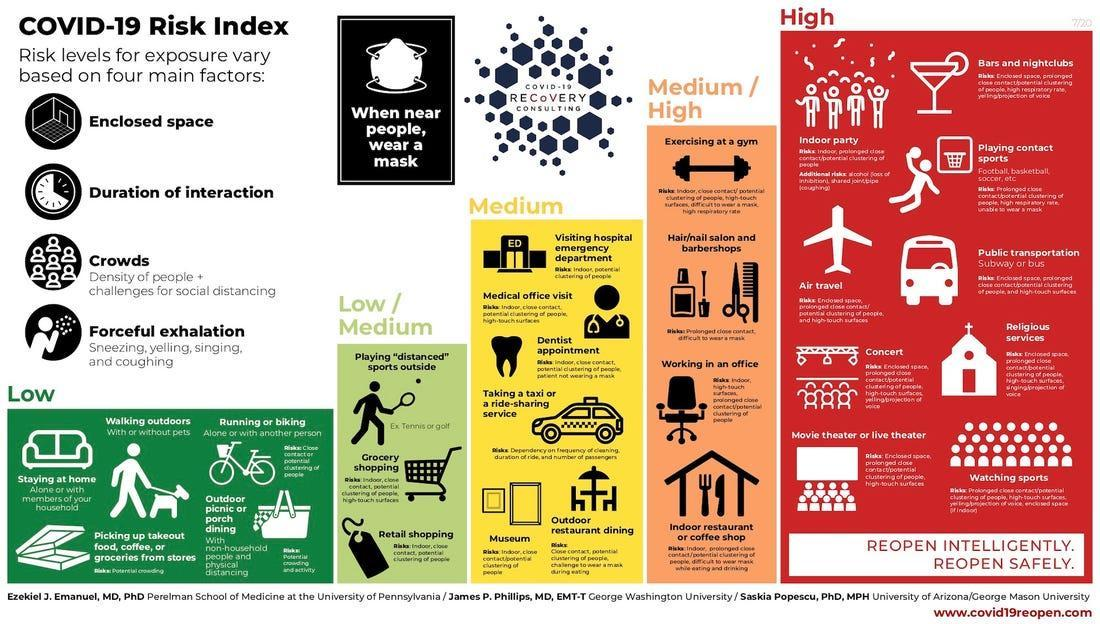Which colour is used to represent the low-risk category of COVID-19 in this infographic image - Yellow, Green, White or Blue?
Answer the question with a short phrase. Green In which risk category of COVID-19 does 'grocery shopping' belong to? Low / Medium Which colour is used to represent the high-risk category of COVID-19 in this infographic image - Green, Yellow, Red or Blue? Red In which risk category of COVID-19 does 'walking outdoors' belong to? Low In which risk category of COVID-19 does 'indoor partying' belong to? High 